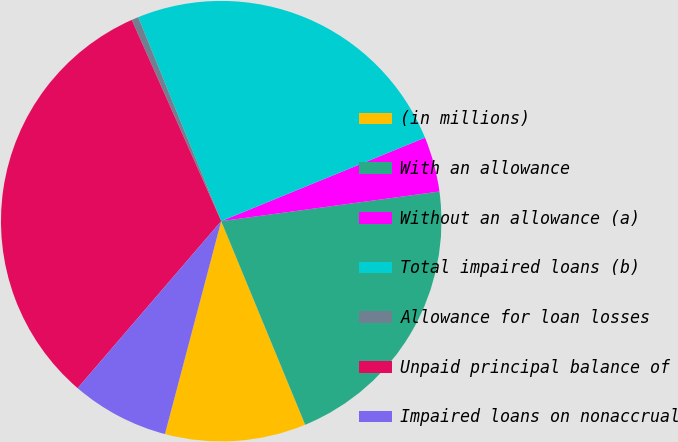Convert chart. <chart><loc_0><loc_0><loc_500><loc_500><pie_chart><fcel>(in millions)<fcel>With an allowance<fcel>Without an allowance (a)<fcel>Total impaired loans (b)<fcel>Allowance for loan losses<fcel>Unpaid principal balance of<fcel>Impaired loans on nonaccrual<nl><fcel>10.34%<fcel>20.92%<fcel>4.04%<fcel>24.96%<fcel>0.51%<fcel>32.04%<fcel>7.19%<nl></chart> 